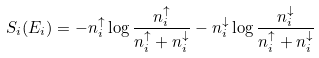<formula> <loc_0><loc_0><loc_500><loc_500>S _ { i } ( E _ { i } ) = - n _ { i } ^ { \uparrow } \log \frac { n _ { i } ^ { \uparrow } } { n _ { i } ^ { \uparrow } + n _ { i } ^ { \downarrow } } - n _ { i } ^ { \downarrow } \log \frac { n _ { i } ^ { \downarrow } } { n _ { i } ^ { \uparrow } + n _ { i } ^ { \downarrow } }</formula> 